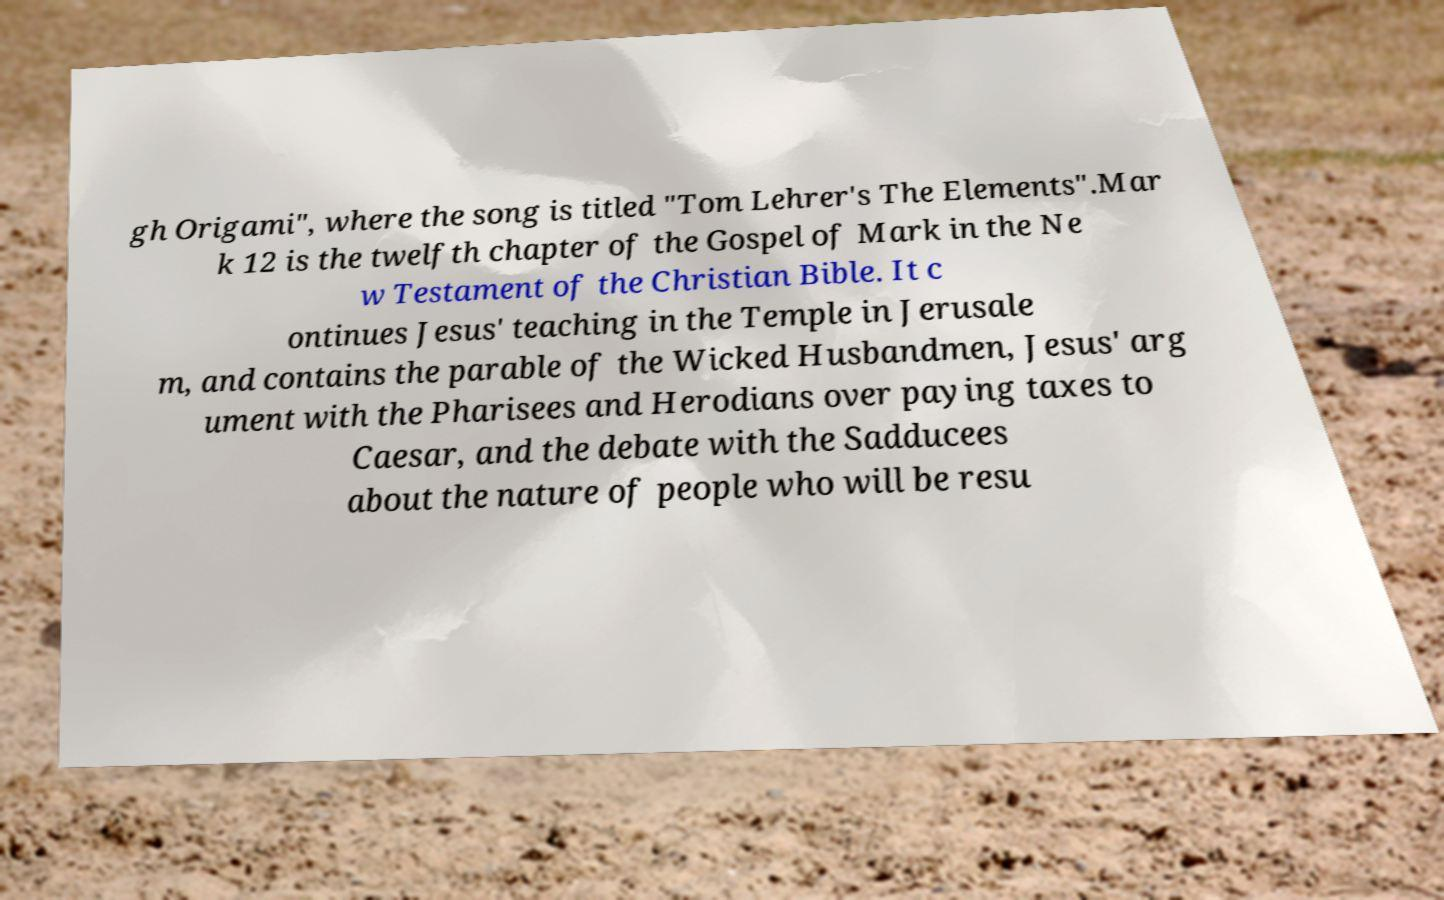There's text embedded in this image that I need extracted. Can you transcribe it verbatim? gh Origami", where the song is titled "Tom Lehrer's The Elements".Mar k 12 is the twelfth chapter of the Gospel of Mark in the Ne w Testament of the Christian Bible. It c ontinues Jesus' teaching in the Temple in Jerusale m, and contains the parable of the Wicked Husbandmen, Jesus' arg ument with the Pharisees and Herodians over paying taxes to Caesar, and the debate with the Sadducees about the nature of people who will be resu 